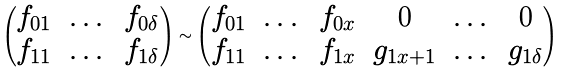<formula> <loc_0><loc_0><loc_500><loc_500>\begin{pmatrix} f _ { 0 1 } & \dots & f _ { 0 \delta } \\ f _ { 1 1 } & \dots & f _ { 1 \delta } \end{pmatrix} \sim \begin{pmatrix} f _ { 0 1 } & \dots & f _ { 0 x } & 0 & \dots & 0 \\ f _ { 1 1 } & \dots & f _ { 1 x } & g _ { 1 x + 1 } & \dots & g _ { 1 \delta } \\ \end{pmatrix}</formula> 